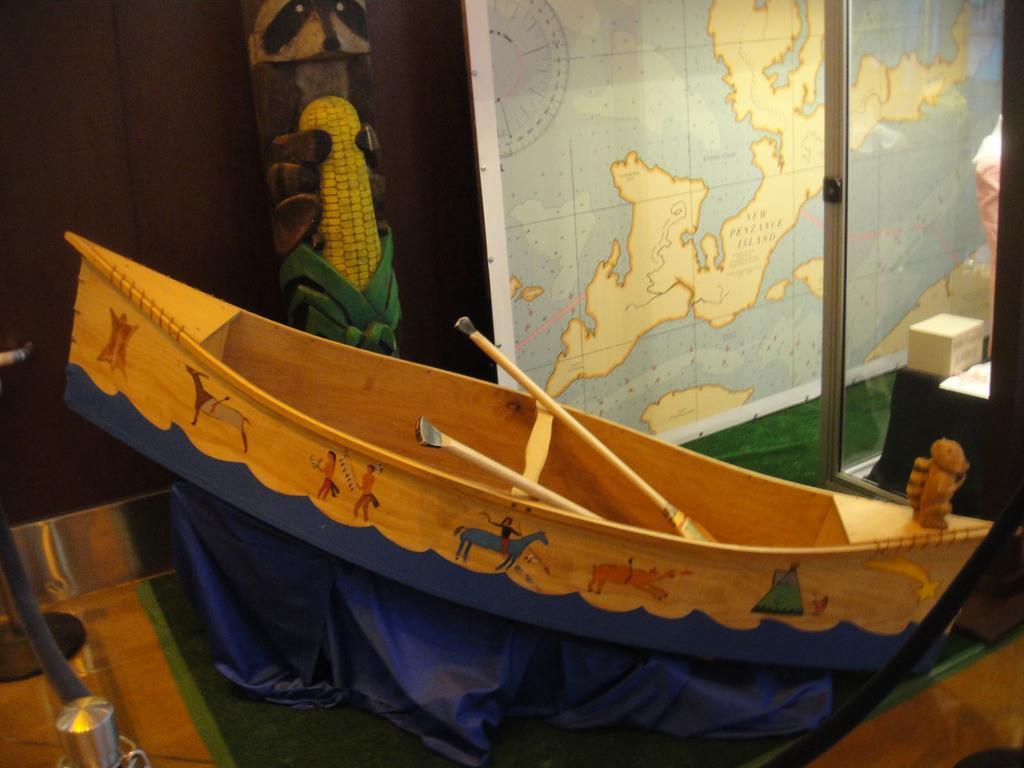Can you describe this image briefly? In this image we can see painting on the boat, paddles, board, map, glass door, carpet, box, rod, wall and things. 